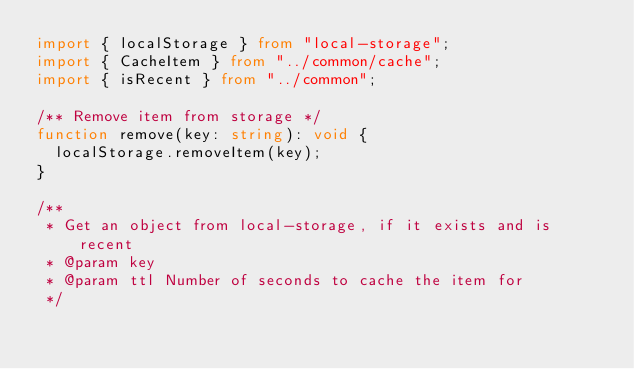<code> <loc_0><loc_0><loc_500><loc_500><_TypeScript_>import { localStorage } from "local-storage";
import { CacheItem } from "../common/cache";
import { isRecent } from "../common";

/** Remove item from storage */
function remove(key: string): void {
  localStorage.removeItem(key);
}

/**
 * Get an object from local-storage, if it exists and is recent
 * @param key
 * @param ttl Number of seconds to cache the item for
 */</code> 